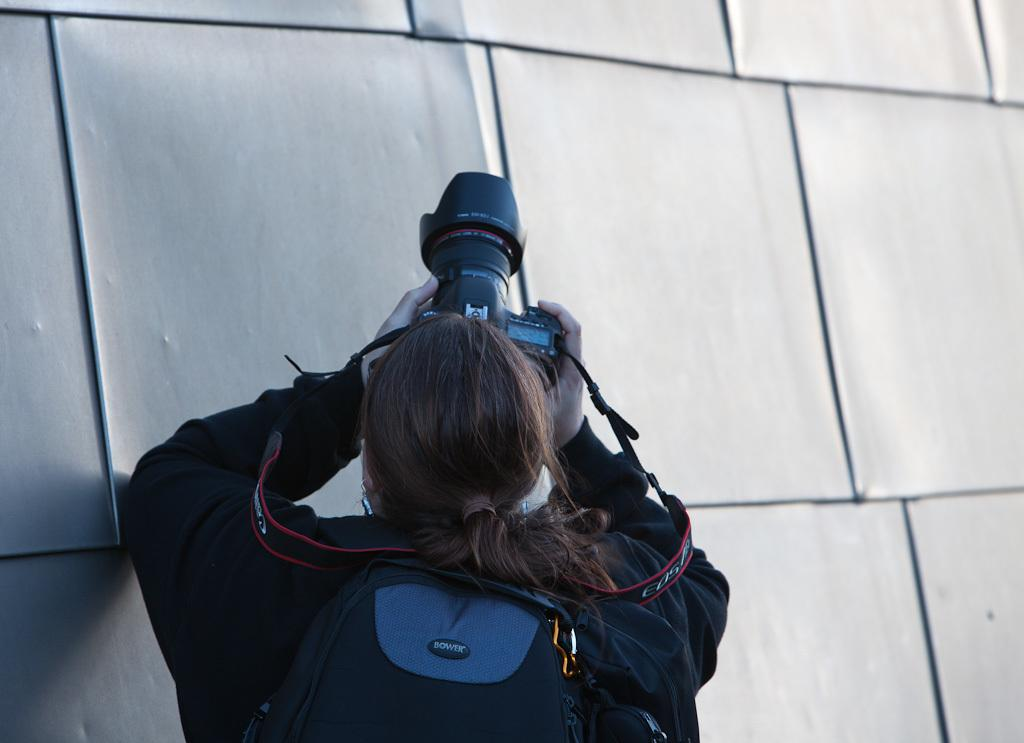What is the main subject of the image? There is a person in the image. What is the person holding in the image? The person is holding a camera. Is the person carrying anything else in the image? Yes, the person is carrying a bag. What is in front of the person in the image? There is a wall in front of the person. What type of plantation can be seen in the background of the image? There is no plantation visible in the image; it only shows a person holding a camera and carrying a bag in front of a wall. 